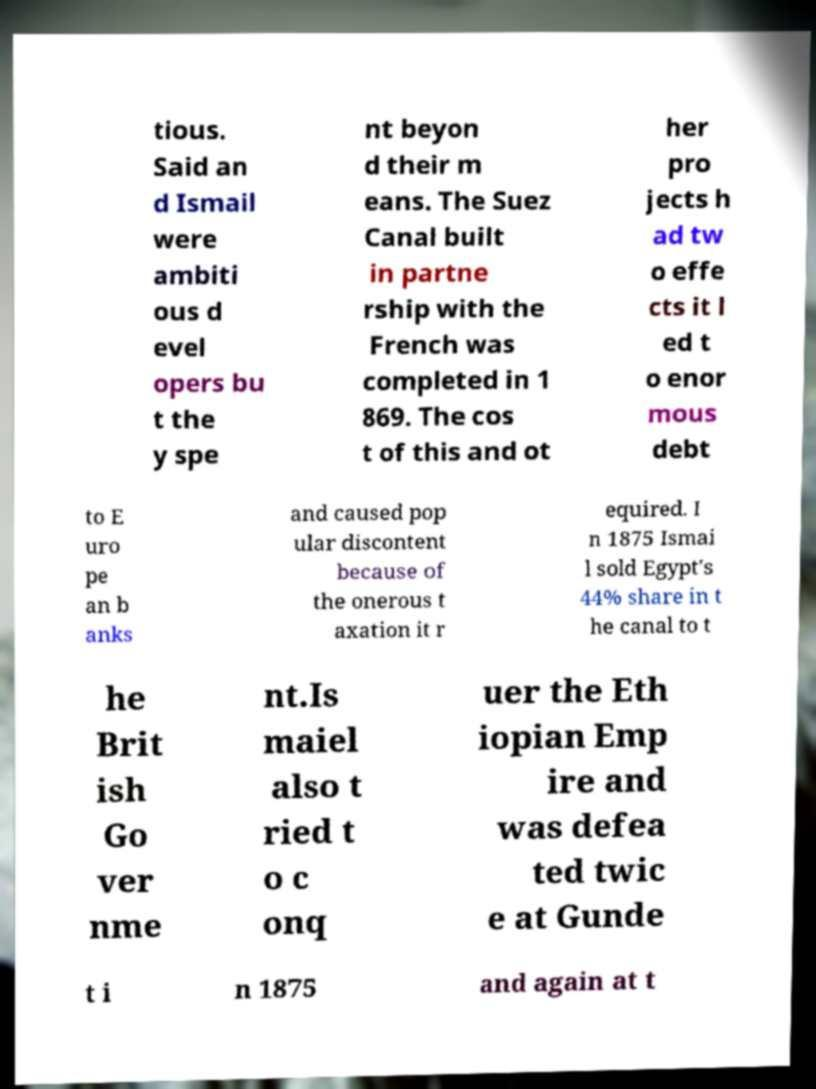I need the written content from this picture converted into text. Can you do that? tious. Said an d Ismail were ambiti ous d evel opers bu t the y spe nt beyon d their m eans. The Suez Canal built in partne rship with the French was completed in 1 869. The cos t of this and ot her pro jects h ad tw o effe cts it l ed t o enor mous debt to E uro pe an b anks and caused pop ular discontent because of the onerous t axation it r equired. I n 1875 Ismai l sold Egypt's 44% share in t he canal to t he Brit ish Go ver nme nt.Is maiel also t ried t o c onq uer the Eth iopian Emp ire and was defea ted twic e at Gunde t i n 1875 and again at t 